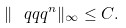<formula> <loc_0><loc_0><loc_500><loc_500>\| \ q q q ^ { n } \| _ { \infty } \leq C .</formula> 